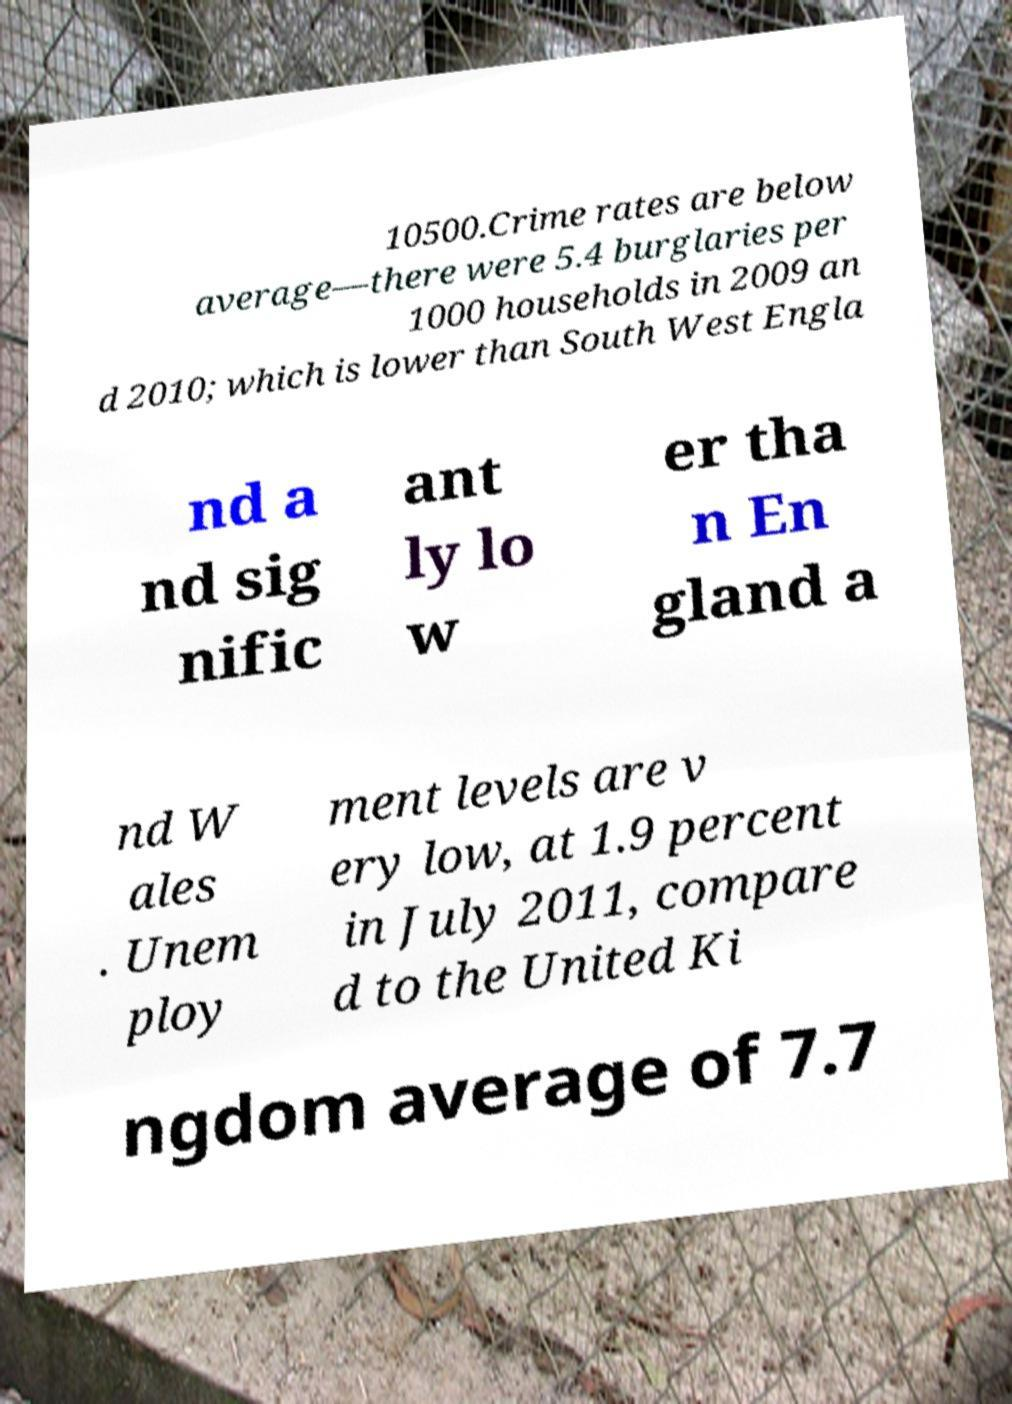Can you read and provide the text displayed in the image?This photo seems to have some interesting text. Can you extract and type it out for me? 10500.Crime rates are below average—there were 5.4 burglaries per 1000 households in 2009 an d 2010; which is lower than South West Engla nd a nd sig nific ant ly lo w er tha n En gland a nd W ales . Unem ploy ment levels are v ery low, at 1.9 percent in July 2011, compare d to the United Ki ngdom average of 7.7 